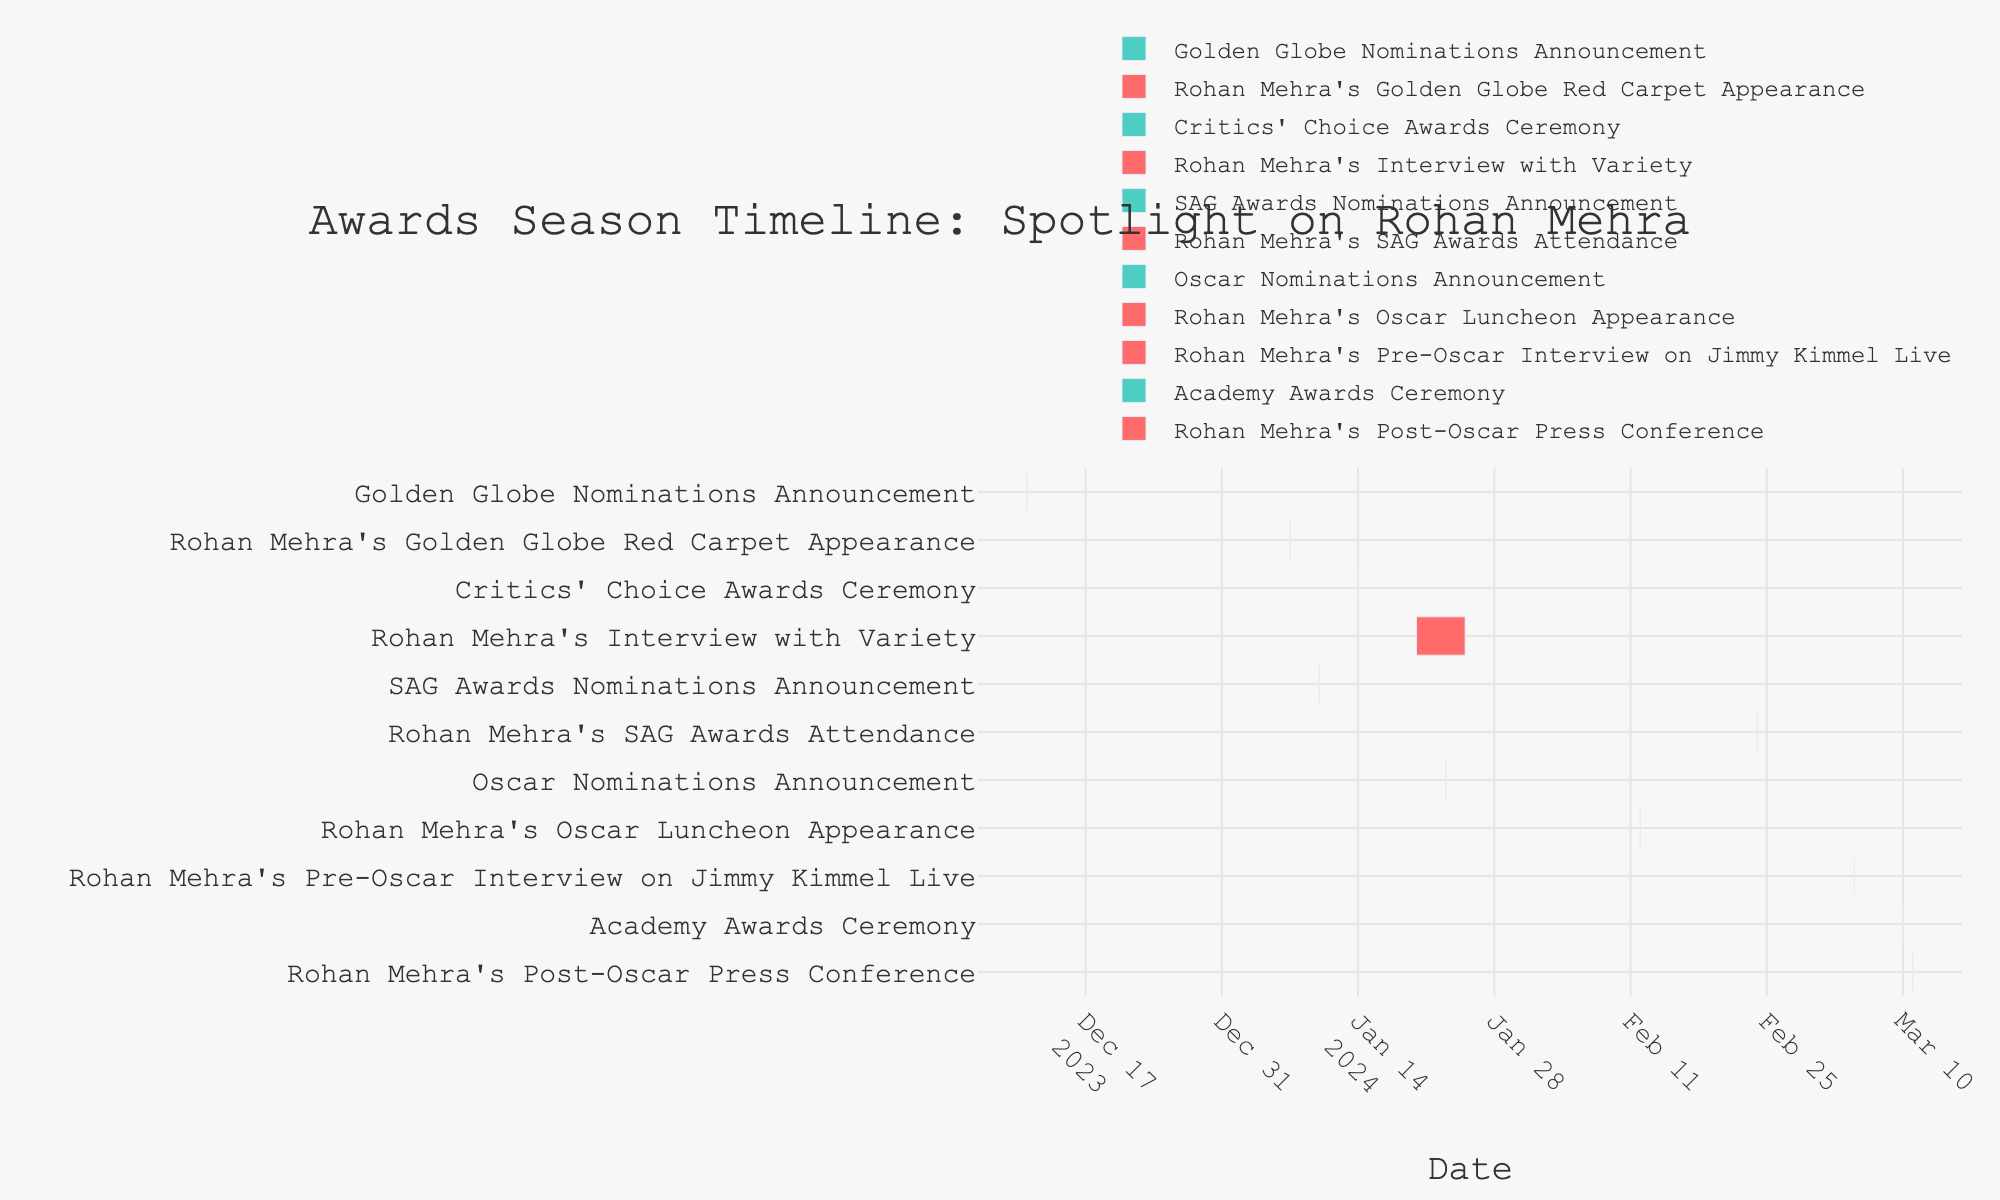When is Rohan Mehra's Golden Globe Red Carpet Appearance scheduled? Look at the timeline event labeled "Rohan Mehra's Golden Globe Red Carpet Appearance". The date range shown is January 7, 2024.
Answer: January 7, 2024 Which event happens directly after the Golden Globe Nominations Announcement? Starting from the "Golden Globe Nominations Announcement" event on December 11, 2023, the next event listed is "Rohan Mehra's Golden Globe Red Carpet Appearance" on January 7, 2024.
Answer: Rohan Mehra's Golden Globe Red Carpet Appearance How many events are dedicated specifically to Rohan Mehra? By counting all events with "Rohan Mehra" in their titles, we find there are six events: Golden Globe Red Carpet Appearance, Interview with Variety, SAG Awards Attendance, Oscar Luncheon Appearance, Pre-Oscar Interview on Jimmy Kimmel Live, and Post-Oscar Press Conference.
Answer: 6 What is the duration of Rohan Mehra's Interview with Variety? The "Rohan Mehra's Interview with Variety" spans from January 20 to January 25, 2024. Counting the days, we find it spans 6 days including both start and end dates.
Answer: 6 days Which comes first: the SAG Awards Nominations Announcement or Rohan Mehra's Interview with Variety? The SAG Awards Nominations Announcement is on January 10, 2024, while Rohan Mehra's Interview with Variety starts on January 20, 2024. Therefore, the SAG Awards Nominations Announcement happens first.
Answer: SAG Awards Nominations Announcement On what date does the Academy Awards Ceremony take place? Look at the event labeled "Academy Awards Ceremony". The date shown is March 10, 2024.
Answer: March 10, 2024 What event comes right after the Academy Awards Ceremony? The event immediately following the "Academy Awards Ceremony" on March 10, 2024, is "Rohan Mehra's Post-Oscar Press Conference" on March 11, 2024.
Answer: Rohan Mehra's Post-Oscar Press Conference Compare the durations of Rohan Mehra's Interview with Variety and his Pre-Oscar Interview on Jimmy Kimmel Live. Which one is longer? The "Rohan Mehra's Interview with Variety" lasts from January 20 to January 25, spanning 6 days. The "Pre-Oscar Interview on Jimmy Kimmel Live" is only on March 5, 2024, lasting 1 day. Therefore, the Interview with Variety is longer.
Answer: Rohan Mehra's Interview with Variety How many days after the Oscar Nominations Announcement does Rohan Mehra's Oscar Luncheon Appearance occur? The "Oscar Nominations Announcement" is on January 23, 2024. "Rohan Mehra's Oscar Luncheon Appearance" takes place on February 12, 2024. The difference between these dates is 20 days.
Answer: 20 days 